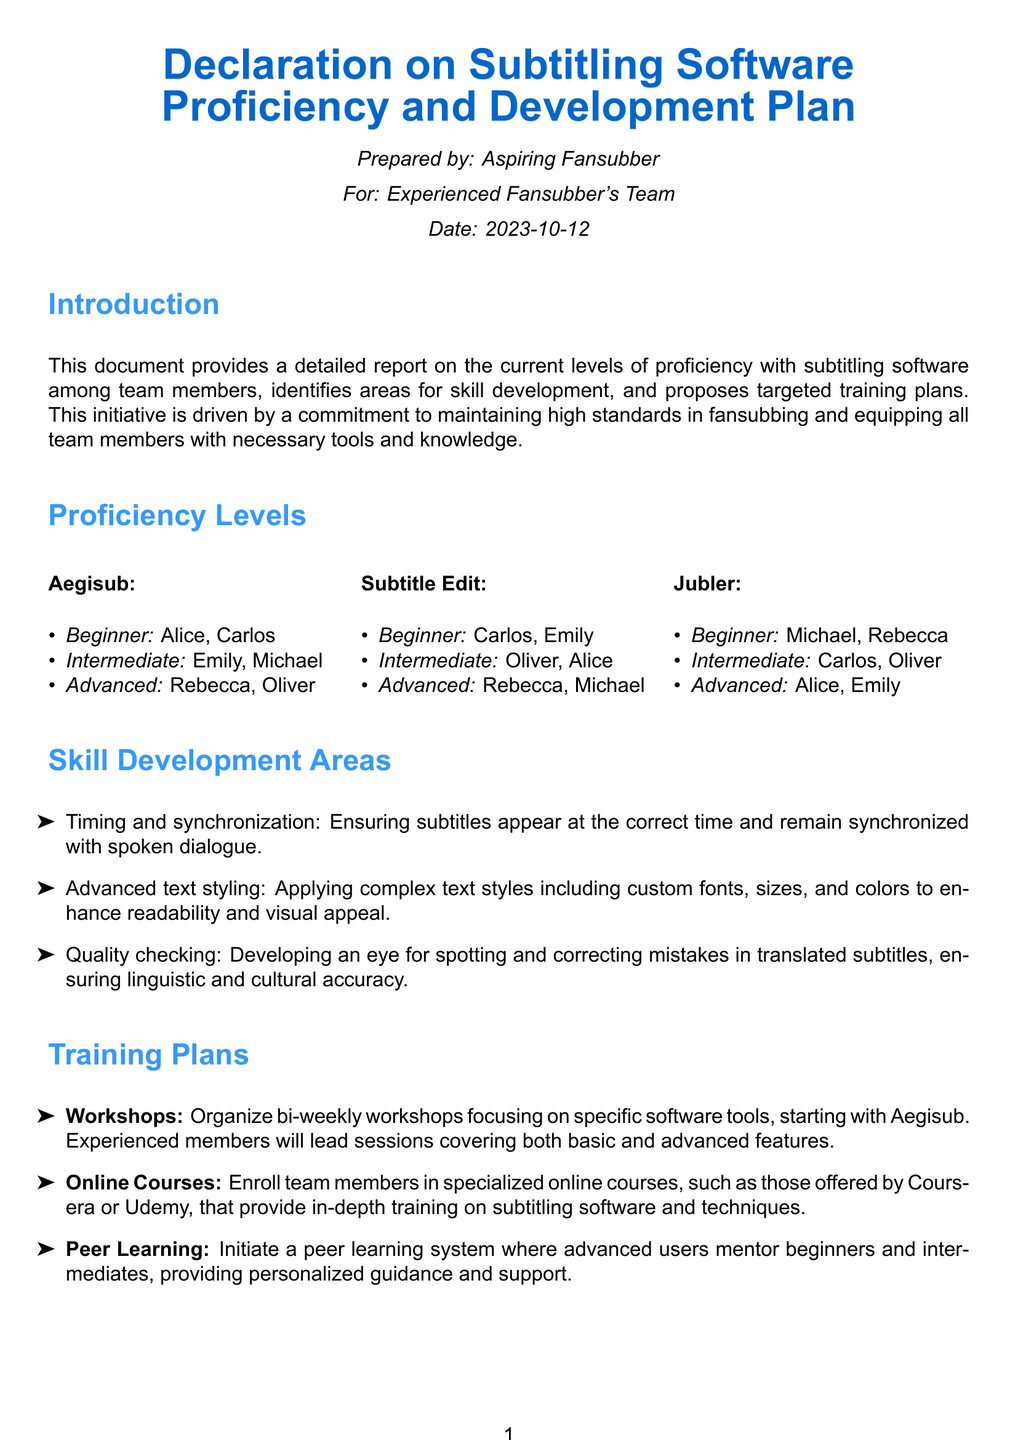What is the title of the document? The title is presented prominently in the document, indicating its main subject matter related to subtitling software proficiency.
Answer: Declaration on Subtitling Software Proficiency and Development Plan Who prepared the document? The document specifies the individual who prepared it, which indicates ownership and responsibility for the content.
Answer: Aspiring Fansubber How many members are listed as beginners in Aegisub? The document includes a clear list of proficiency levels, allowing us to count the number of beginners specifically.
Answer: 2 Which software has the highest number of advanced users? By comparing the lists, we can determine which software includes the most individuals categorized as advanced.
Answer: Subtitle Edit What is one area identified for skill development? The document explicitly outlines areas that require improvement, giving clear examples that can be referenced.
Answer: Timing and synchronization How often are workshops planned? The training plan section specifies the frequency of the proposed workshops, which informs about the continuous development approach.
Answer: Bi-weekly Which online platforms are suggested for courses? The document mentions specific platforms that offer relevant training, helping users identify where to seek further education.
Answer: Coursera or Udemy Who will lead the workshops? The document provides details about the leadership structure of the proposed training sessions, indicating who will facilitate learning.
Answer: Experienced members What is the date of document preparation? The document includes the preparation date, showcasing the timeline related to the initiative being discussed.
Answer: 2023-10-12 